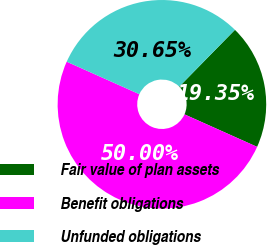<chart> <loc_0><loc_0><loc_500><loc_500><pie_chart><fcel>Fair value of plan assets<fcel>Benefit obligations<fcel>Unfunded obligations<nl><fcel>19.35%<fcel>50.0%<fcel>30.65%<nl></chart> 